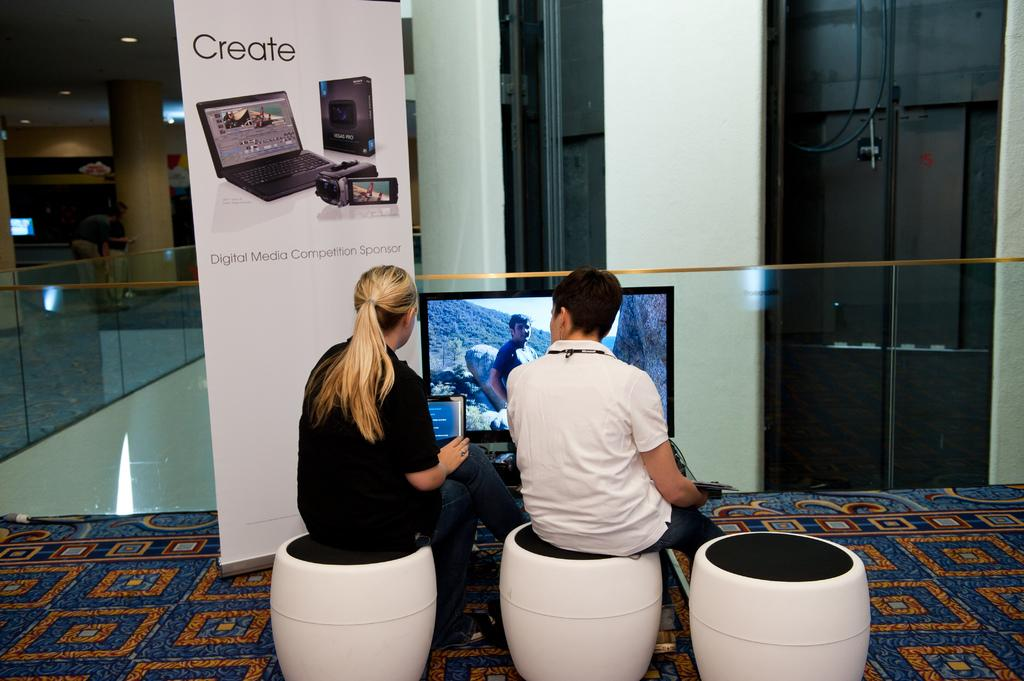Provide a one-sentence caption for the provided image. A man and a woman are sitting on seats beneath a sign that says Create. 